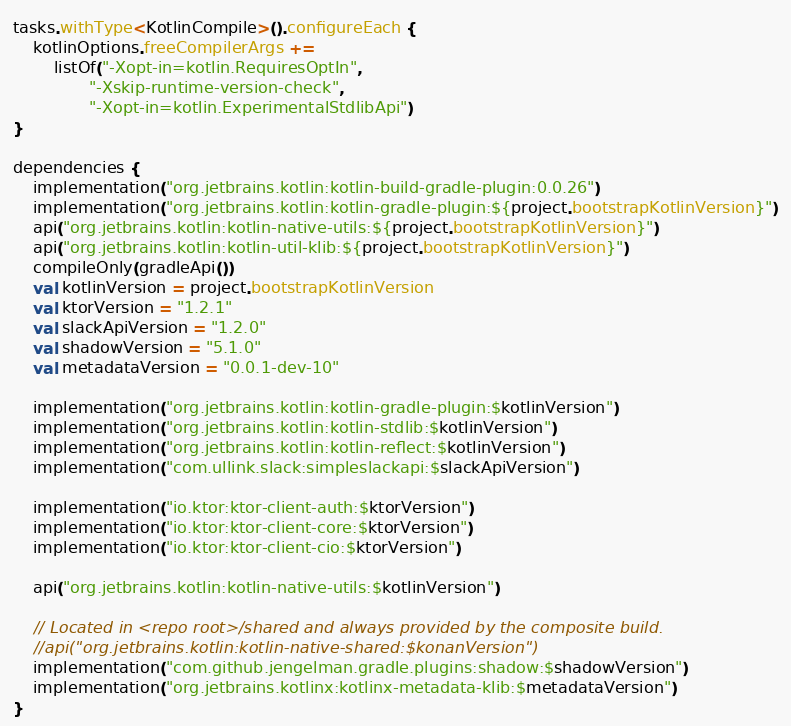<code> <loc_0><loc_0><loc_500><loc_500><_Kotlin_>tasks.withType<KotlinCompile>().configureEach {
    kotlinOptions.freeCompilerArgs +=
        listOf("-Xopt-in=kotlin.RequiresOptIn",
               "-Xskip-runtime-version-check",
               "-Xopt-in=kotlin.ExperimentalStdlibApi")
}

dependencies {
    implementation("org.jetbrains.kotlin:kotlin-build-gradle-plugin:0.0.26")
    implementation("org.jetbrains.kotlin:kotlin-gradle-plugin:${project.bootstrapKotlinVersion}")
    api("org.jetbrains.kotlin:kotlin-native-utils:${project.bootstrapKotlinVersion}")
    api("org.jetbrains.kotlin:kotlin-util-klib:${project.bootstrapKotlinVersion}")
    compileOnly(gradleApi())
    val kotlinVersion = project.bootstrapKotlinVersion
    val ktorVersion = "1.2.1"
    val slackApiVersion = "1.2.0"
    val shadowVersion = "5.1.0"
    val metadataVersion = "0.0.1-dev-10"

    implementation("org.jetbrains.kotlin:kotlin-gradle-plugin:$kotlinVersion")
    implementation("org.jetbrains.kotlin:kotlin-stdlib:$kotlinVersion")
    implementation("org.jetbrains.kotlin:kotlin-reflect:$kotlinVersion")
    implementation("com.ullink.slack:simpleslackapi:$slackApiVersion")

    implementation("io.ktor:ktor-client-auth:$ktorVersion")
    implementation("io.ktor:ktor-client-core:$ktorVersion")
    implementation("io.ktor:ktor-client-cio:$ktorVersion")

    api("org.jetbrains.kotlin:kotlin-native-utils:$kotlinVersion")

    // Located in <repo root>/shared and always provided by the composite build.
    //api("org.jetbrains.kotlin:kotlin-native-shared:$konanVersion")
    implementation("com.github.jengelman.gradle.plugins:shadow:$shadowVersion")
    implementation("org.jetbrains.kotlinx:kotlinx-metadata-klib:$metadataVersion")
}
</code> 